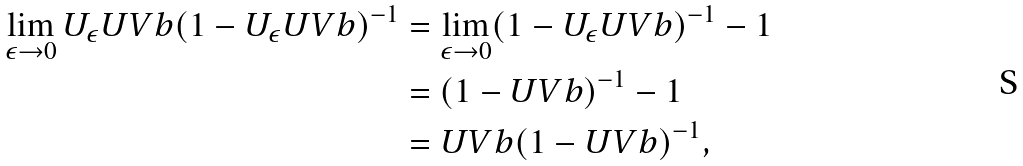Convert formula to latex. <formula><loc_0><loc_0><loc_500><loc_500>\lim _ { \epsilon \to 0 } U _ { \epsilon } U V b ( 1 - U _ { \epsilon } U V b ) ^ { - 1 } & = \lim _ { \epsilon \to 0 } ( 1 - U _ { \epsilon } U V b ) ^ { - 1 } - 1 \\ & = ( 1 - U V b ) ^ { - 1 } - 1 \\ & = U V b ( 1 - U V b ) ^ { - 1 } ,</formula> 